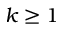<formula> <loc_0><loc_0><loc_500><loc_500>k \geq 1</formula> 